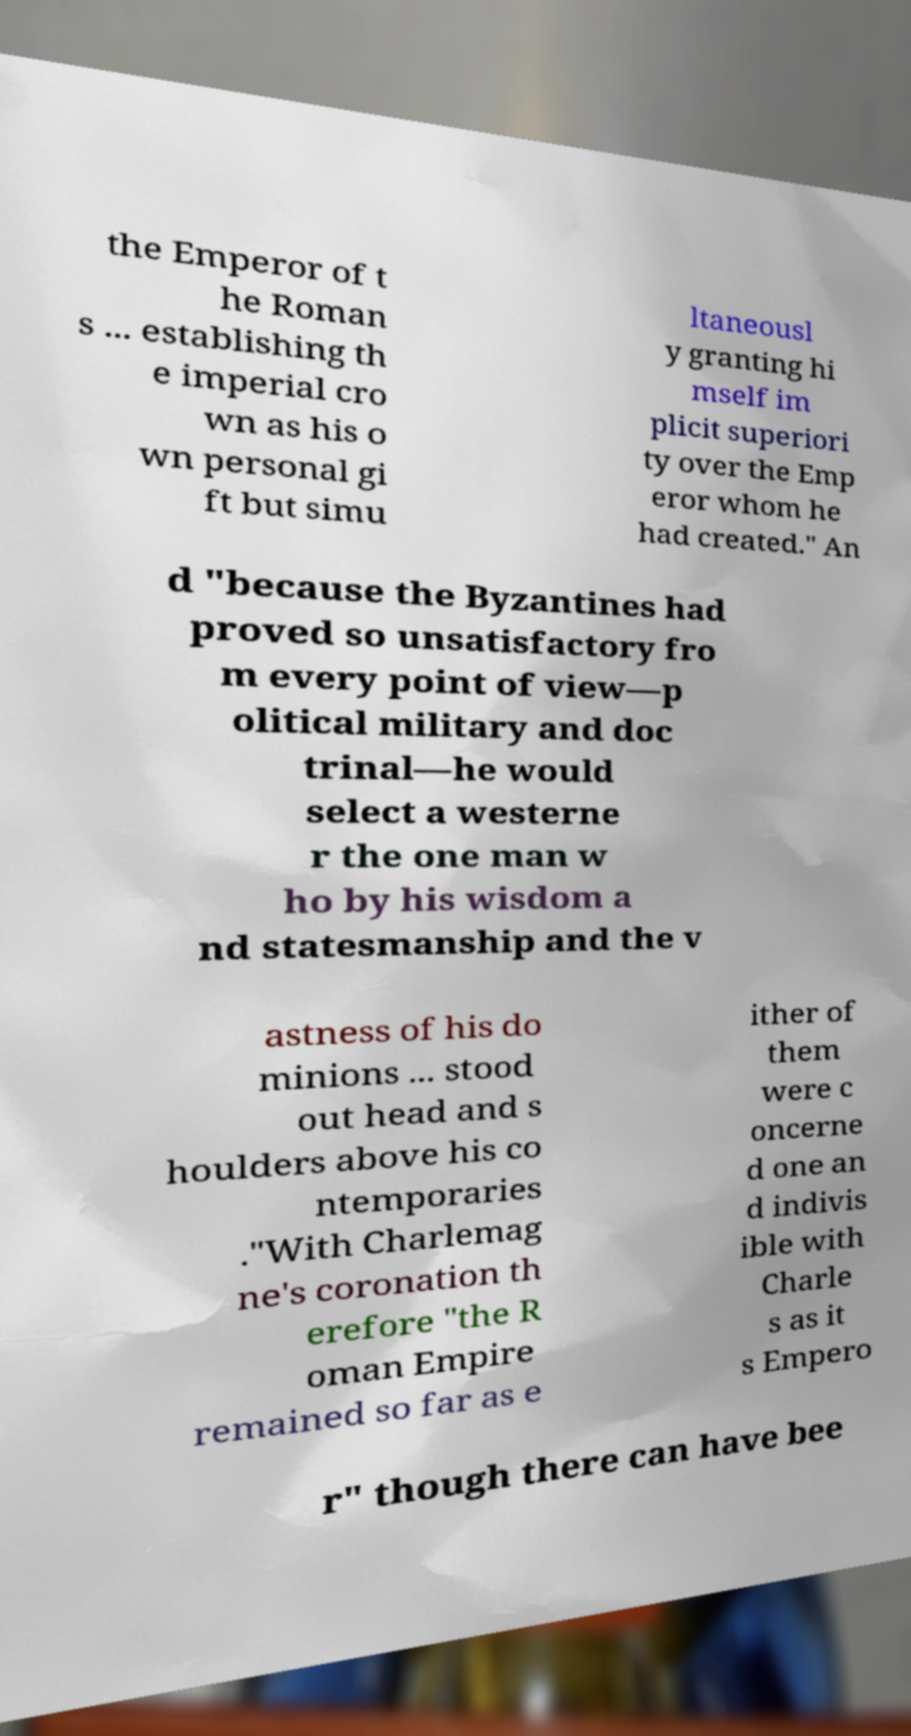For documentation purposes, I need the text within this image transcribed. Could you provide that? the Emperor of t he Roman s ... establishing th e imperial cro wn as his o wn personal gi ft but simu ltaneousl y granting hi mself im plicit superiori ty over the Emp eror whom he had created." An d "because the Byzantines had proved so unsatisfactory fro m every point of view—p olitical military and doc trinal—he would select a westerne r the one man w ho by his wisdom a nd statesmanship and the v astness of his do minions ... stood out head and s houlders above his co ntemporaries ."With Charlemag ne's coronation th erefore "the R oman Empire remained so far as e ither of them were c oncerne d one an d indivis ible with Charle s as it s Empero r" though there can have bee 